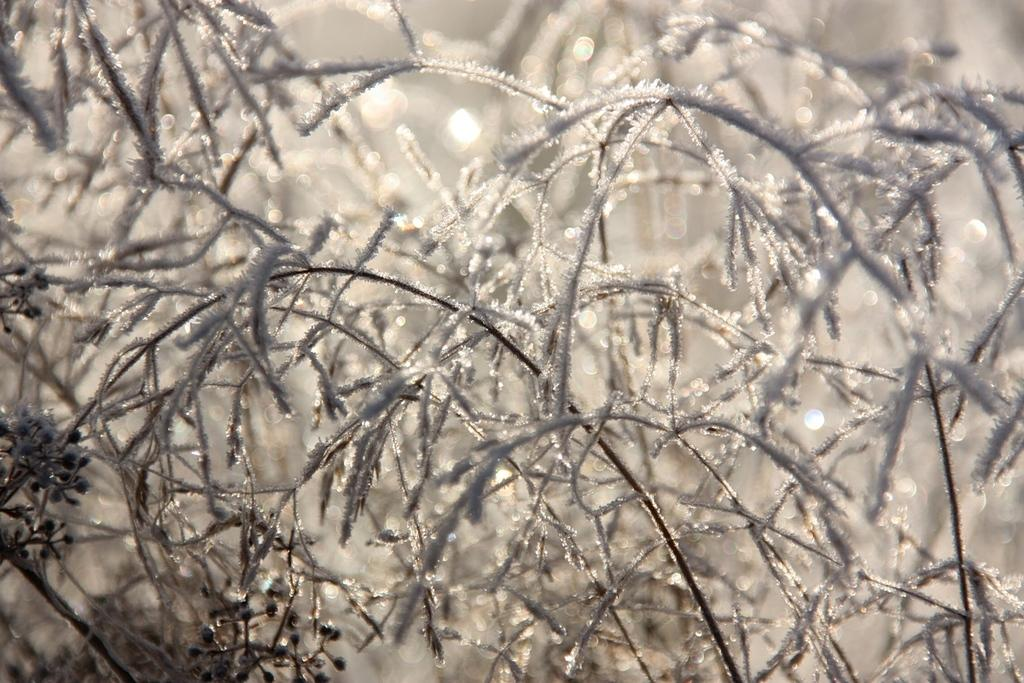What is the main subject of the image? The main subject of the image is a group of plants. What type of army can be seen marching through the plants in the image? There is no army present in the image; it only features a group of plants. What type of fruit can be seen hanging from the plants in the image? There is no fruit present in the image; it only features a group of plants. 